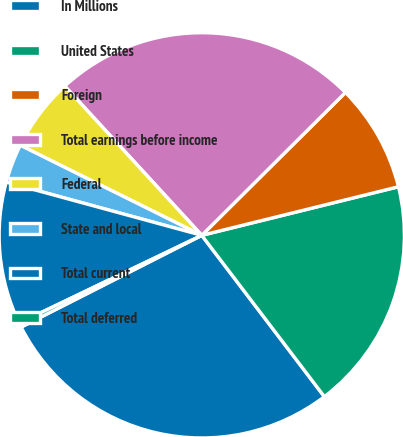<chart> <loc_0><loc_0><loc_500><loc_500><pie_chart><fcel>In Millions<fcel>United States<fcel>Foreign<fcel>Total earnings before income<fcel>Federal<fcel>State and local<fcel>Total current<fcel>Total deferred<nl><fcel>27.86%<fcel>18.51%<fcel>8.6%<fcel>24.36%<fcel>5.85%<fcel>3.1%<fcel>11.36%<fcel>0.35%<nl></chart> 